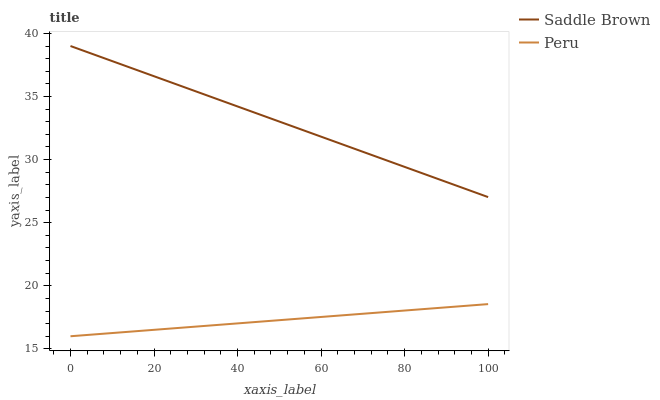Does Peru have the minimum area under the curve?
Answer yes or no. Yes. Does Saddle Brown have the maximum area under the curve?
Answer yes or no. Yes. Does Peru have the maximum area under the curve?
Answer yes or no. No. Is Saddle Brown the smoothest?
Answer yes or no. Yes. Is Peru the roughest?
Answer yes or no. Yes. Is Peru the smoothest?
Answer yes or no. No. Does Peru have the lowest value?
Answer yes or no. Yes. Does Saddle Brown have the highest value?
Answer yes or no. Yes. Does Peru have the highest value?
Answer yes or no. No. Is Peru less than Saddle Brown?
Answer yes or no. Yes. Is Saddle Brown greater than Peru?
Answer yes or no. Yes. Does Peru intersect Saddle Brown?
Answer yes or no. No. 